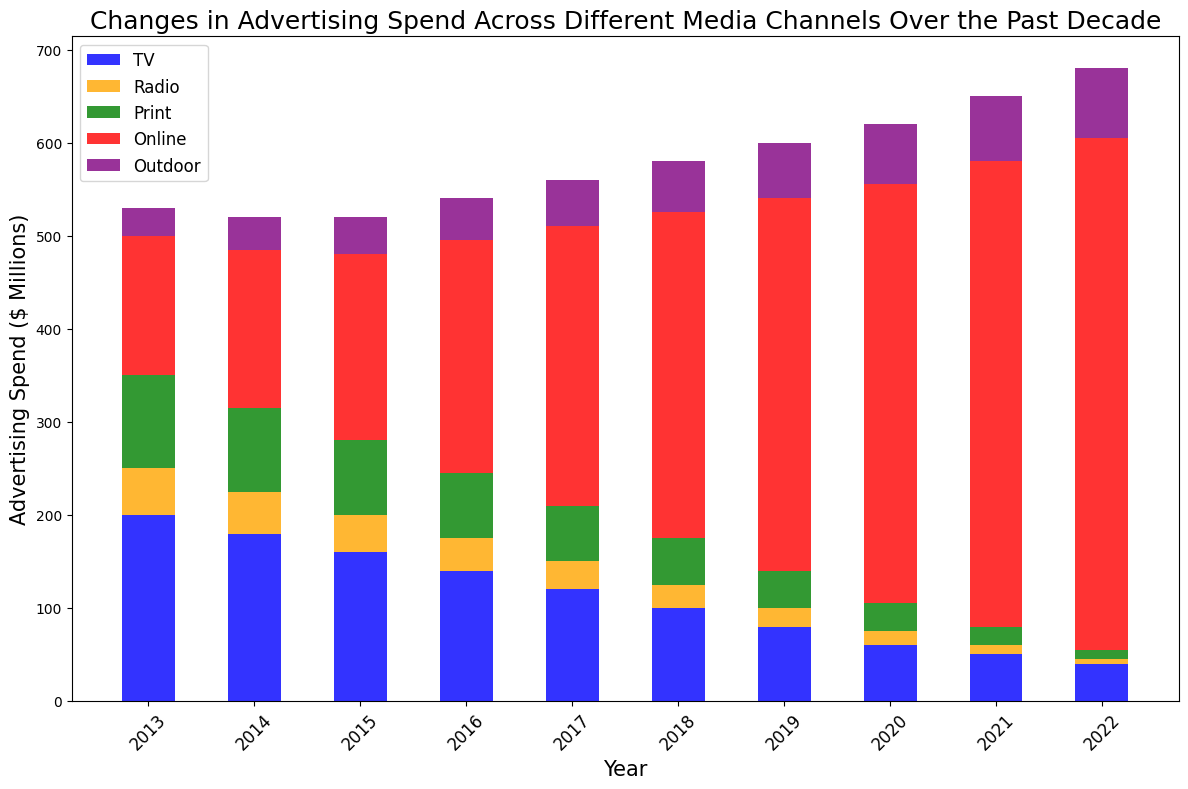What's the trend in TV advertising spend from 2013 to 2022? To find the trend, observe the heights of the blue bars labeled 'TV' in each year from 2013 to 2022. Notice that the height decreases consistently every year. This indicates a declining trend in TV advertising spend over the decade.
Answer: Declining Which year had the highest spending on online advertising? Look for the tallest segment of the red bars which represent 'Online' spending across all years. The tallest red bar segment occurs in 2022.
Answer: 2022 Compare print advertising spend in 2013 to 2022. Has it increased or decreased? Check the heights of the green bars labeled 'Print' for the years 2013 and 2022. In 2013, the green segment is higher than in 2022. Thus, print advertising spend has decreased.
Answer: Decreased Sum up the total advertising spend across all channels for the year 2016. Add the heights of all bar segments for 2016: TV (140) + Radio (35) + Print (70) + Online (250) + Outdoor (45) = 540.
Answer: 540 Which media channel shows a continuous increase in spend over the decade? Check the bar segments for each media channel across all years. The red segment (Online) increases every year indicating a continuous rise in online advertising spend.
Answer: Online In which year did radio advertising spend dip below TV advertising spend for the first time in the data? Examine the heights of the orange (Radio) and blue (TV) segments across years, noting when Radio first becomes less than TV. In 2014, TV spend is 180 and Radio spend is 45. By 2013, Radio was not below TV; hence, 2014 is the first year it dips below.
Answer: 2014 What is the average annual spending on outdoor advertising over the entire period? To find the average, sum the outdoor spend for each year and divide by the number of years. (30 + 35 + 40 + 45 + 50 + 55 + 60 + 65 + 70 + 75) = 525; 525 / 10 = 52.5
Answer: 52.5 Which media channel had the lowest spend in 2020? Observe and compare the heights of the bar segments for 2020. The smallest segment is the green one, representing 'Print' spend.
Answer: Print Was there a year where the combined spend on Radio and Outdoor was higher than TV in that same year? For each year, sum the Radio (orange segment) and Outdoor (purple segment), then compare to TV (blue segment). In 2017, Radio (30) + Outdoor (50) = 80, which is equal to TV (120). However, comparing spends in earlier years shows no combination surpasses TV.
Answer: No By how much did TV advertising spend decline from 2013 to 2022? Subtract the TV spend in 2022 from that in 2013: 200 (2013) - 40 (2022) = 160.
Answer: 160 